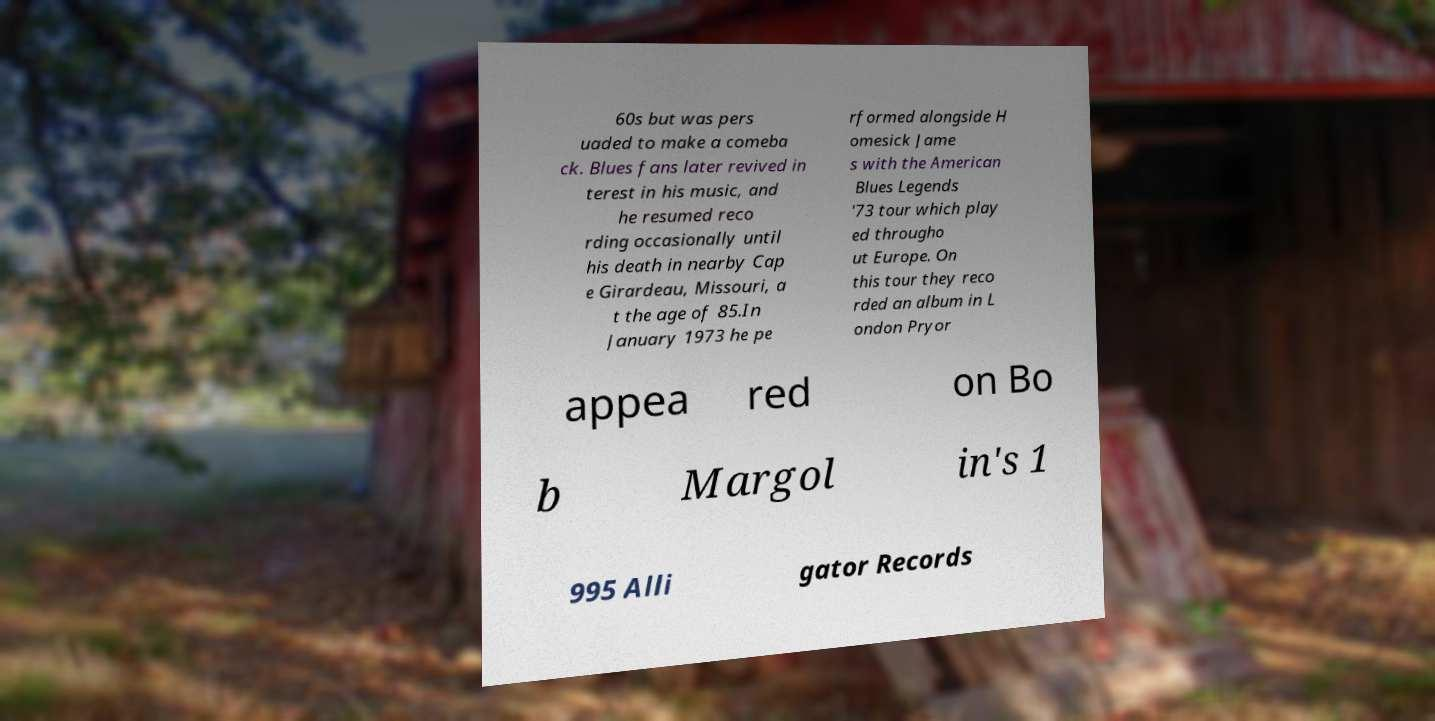Can you read and provide the text displayed in the image?This photo seems to have some interesting text. Can you extract and type it out for me? 60s but was pers uaded to make a comeba ck. Blues fans later revived in terest in his music, and he resumed reco rding occasionally until his death in nearby Cap e Girardeau, Missouri, a t the age of 85.In January 1973 he pe rformed alongside H omesick Jame s with the American Blues Legends '73 tour which play ed througho ut Europe. On this tour they reco rded an album in L ondon Pryor appea red on Bo b Margol in's 1 995 Alli gator Records 